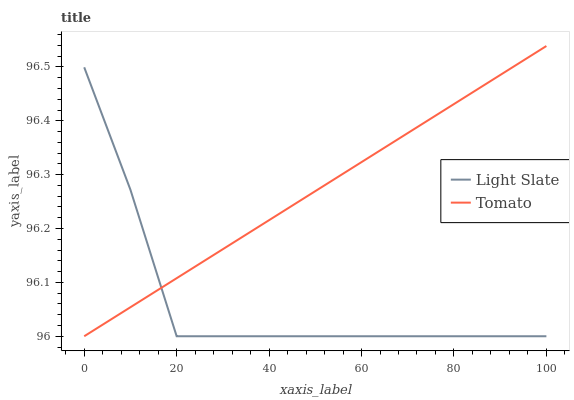Does Light Slate have the minimum area under the curve?
Answer yes or no. Yes. Does Tomato have the maximum area under the curve?
Answer yes or no. Yes. Does Tomato have the minimum area under the curve?
Answer yes or no. No. Is Tomato the smoothest?
Answer yes or no. Yes. Is Light Slate the roughest?
Answer yes or no. Yes. Is Tomato the roughest?
Answer yes or no. No. Does Light Slate have the lowest value?
Answer yes or no. Yes. Does Tomato have the highest value?
Answer yes or no. Yes. Does Light Slate intersect Tomato?
Answer yes or no. Yes. Is Light Slate less than Tomato?
Answer yes or no. No. Is Light Slate greater than Tomato?
Answer yes or no. No. 